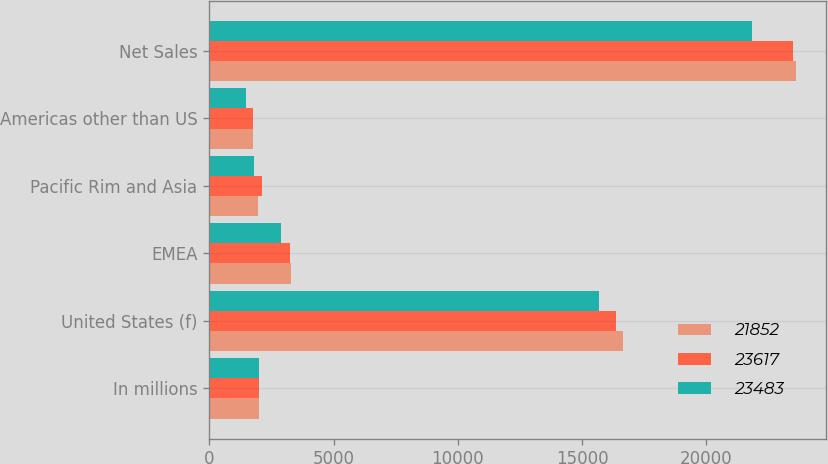Convert chart. <chart><loc_0><loc_0><loc_500><loc_500><stacked_bar_chart><ecel><fcel>In millions<fcel>United States (f)<fcel>EMEA<fcel>Pacific Rim and Asia<fcel>Americas other than US<fcel>Net Sales<nl><fcel>21852<fcel>2014<fcel>16645<fcel>3273<fcel>1951<fcel>1748<fcel>23617<nl><fcel>23617<fcel>2013<fcel>16371<fcel>3250<fcel>2114<fcel>1748<fcel>23483<nl><fcel>23483<fcel>2012<fcel>15689<fcel>2886<fcel>1816<fcel>1461<fcel>21852<nl></chart> 